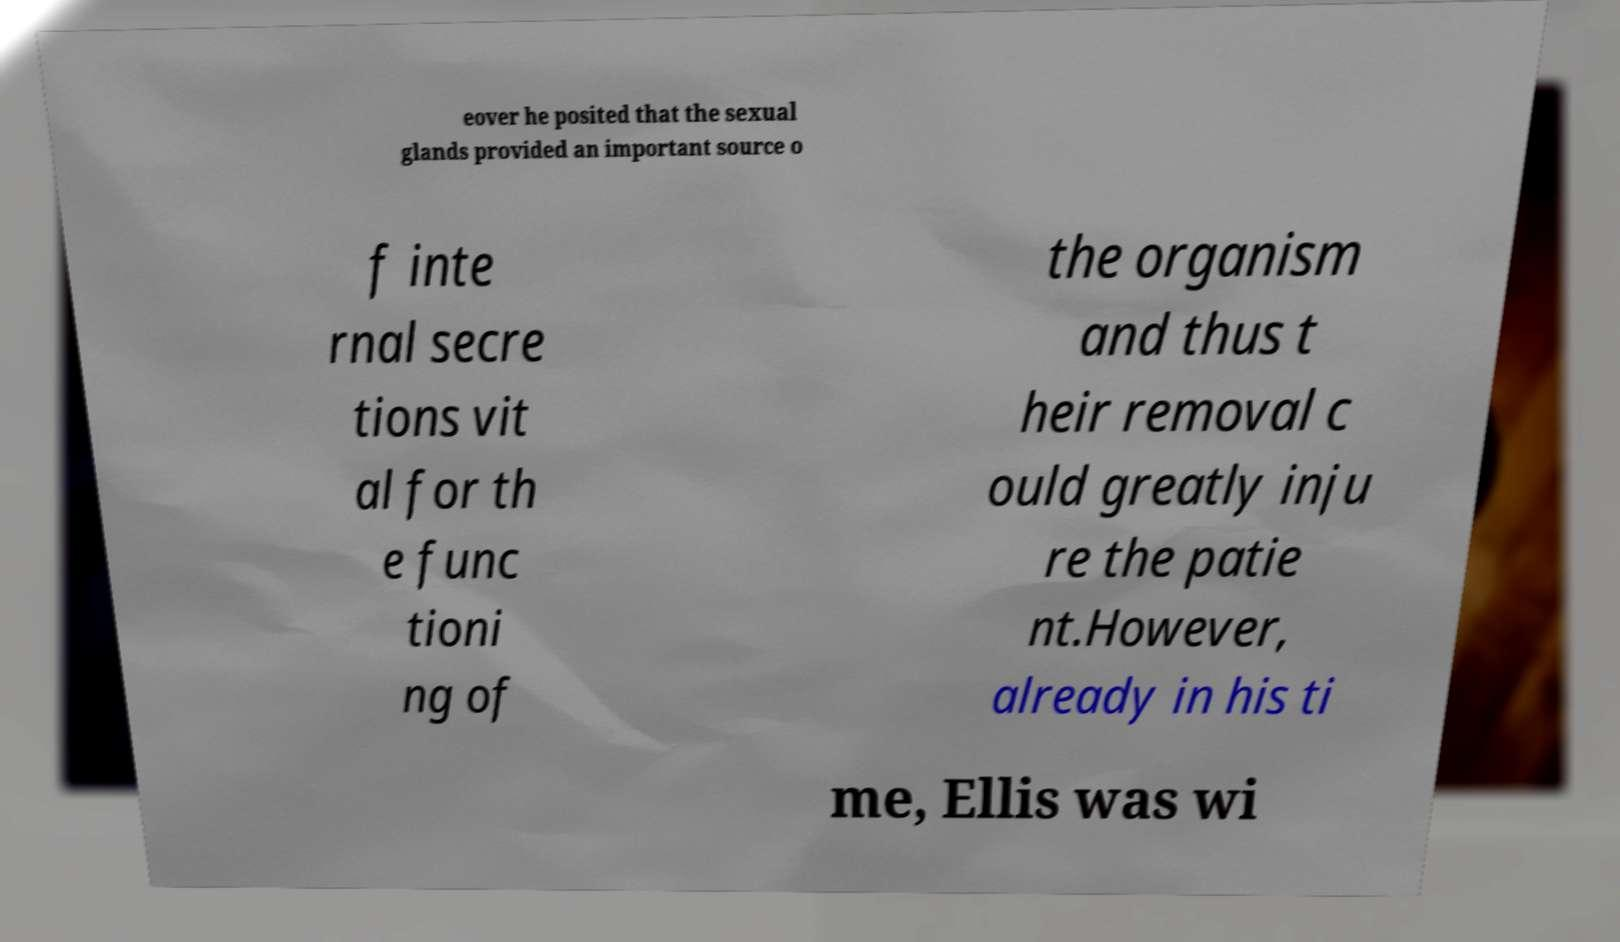Please identify and transcribe the text found in this image. eover he posited that the sexual glands provided an important source o f inte rnal secre tions vit al for th e func tioni ng of the organism and thus t heir removal c ould greatly inju re the patie nt.However, already in his ti me, Ellis was wi 